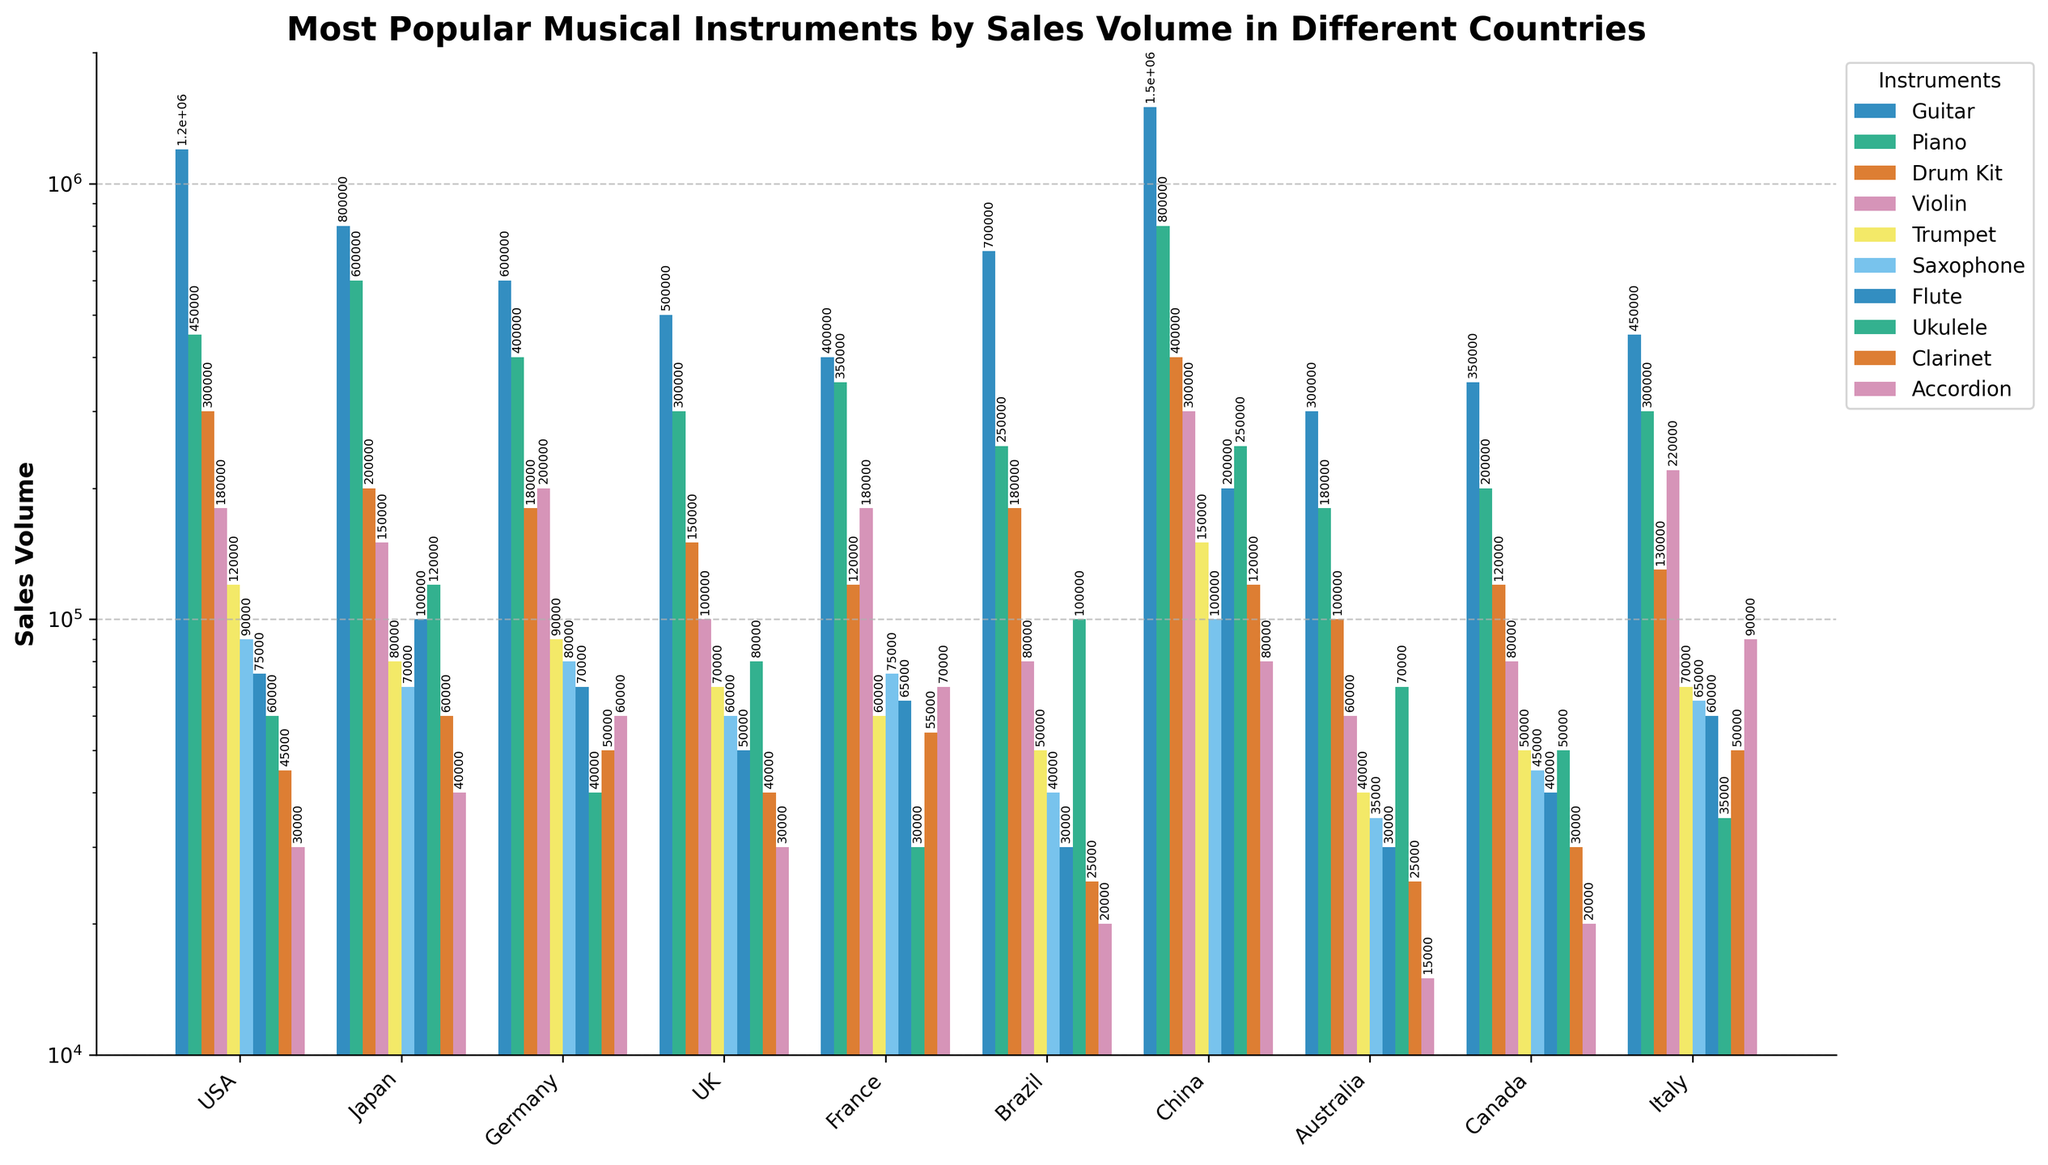Which country has the highest sales volume for guitars? From the figure, observe the height of the bars representing guitar sales. The tallest bar for guitars is seen for China.
Answer: China Compare the sales volume of drum kits in the USA and Japan. Which country has higher sales? Looking at the bars for drum kits, we see that the bar representing the USA is higher than that of Japan.
Answer: USA What's the combined sales volume of pianos and violins in Germany? From the figure, find the sales volumes of pianos and violins in Germany (400,000 and 200,000 respectively) and add them together: 400,000 + 200,000 = 600,000.
Answer: 600,000 Which instrument has the lowest sales volume in Australia? Identify the shortest bar in the group representing Australia. The lowest bar pertains to the accordion.
Answer: Accordion What is the difference in trumpet sales between France and Brazil? Locate the trumpet sales volumes for both France and Brazil (60,000 and 50,000 respectively) and subtract the smaller from the larger: 60,000 - 50,000 = 10,000.
Answer: 10,000 Which country has the smallest sales volume for clarinets? Find the shortest bar corresponding to clarinet sales across all countries, which is Brazil.
Answer: Brazil What's the total sales volume of flutes in Japan, Australia, and Canada combined? Sum up the sales volumes of flutes in these three countries: Japan (100,000), Australia (30,000), and Canada (40,000). The total is 100,000 + 30,000 + 40,000 = 170,000.
Answer: 170,000 Is the sales volume of saxophones higher in Germany or in Italy? Compare the bars representing saxophone sales in Germany and Italy. The bar for Germany is higher.
Answer: Germany What is the average sales volume of ukuleles across all countries? Determine the sales volumes of ukuleles in each country, then find the average: (60,000 + 120,000 + 40,000 + 80,000 + 30,000 + 100,000 + 250,000 + 70,000 + 50,000 + 35,000) / 10 = 835,000 / 10 = 83,500.
Answer: 83,500 Does Canada have higher sales for pianos or violins? Compare the heights of the bars for piano and violin sales in Canada. The piano bar is higher at 200,000 compared to 80,000 for violins.
Answer: Pianos 